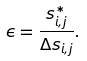Convert formula to latex. <formula><loc_0><loc_0><loc_500><loc_500>\epsilon = \frac { s ^ { * } _ { i , j } } { \Delta s _ { i , j } } .</formula> 